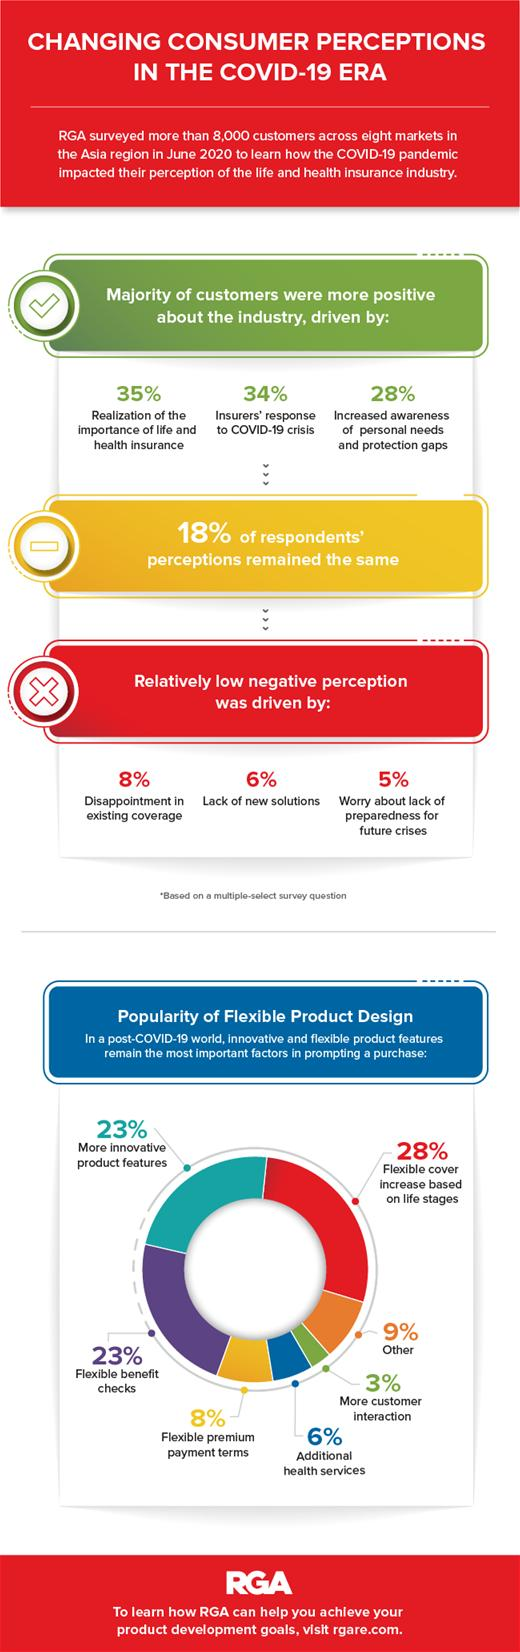Draw attention to some important aspects in this diagram. The least important factor in product design, according to the pie chart, is more customer interaction. The factor that has a more significant impact on forming a negative perception of the industry is disappointment with existing coverage. Realizing the importance of life and health insurance is a key factor in forming a positive perception of the industry. In product design, there are two factors that are equally important: innovative product features and flexible benefit checks. 31% of flexible benefit checks and premium payment terms are taken together. 